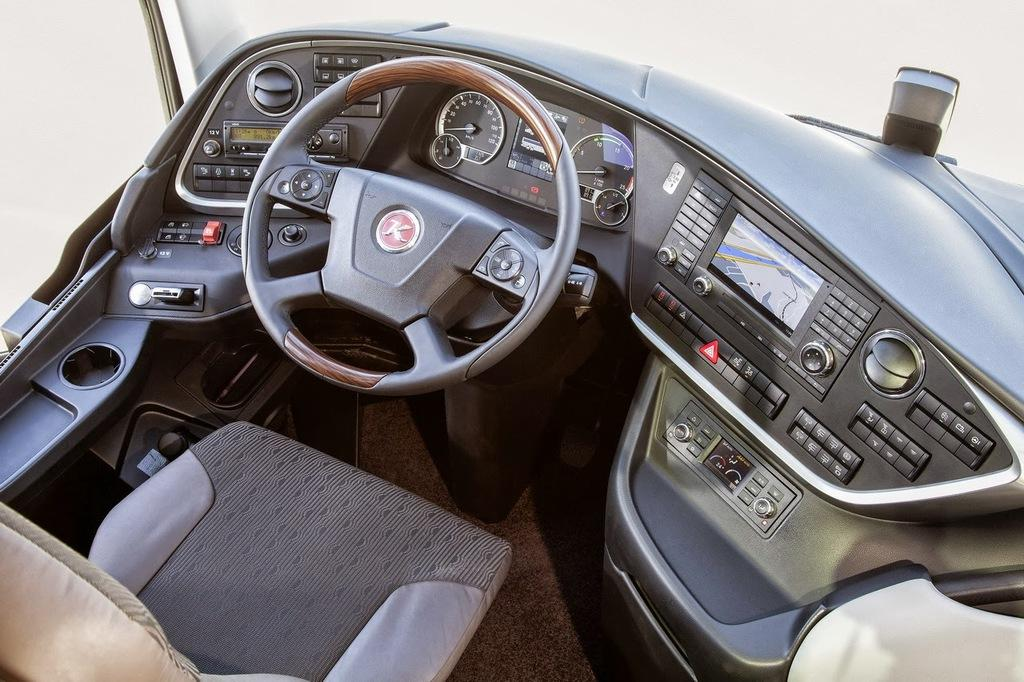What type of location is depicted in the image? The image is an inside view of a vehicle. What is the primary control mechanism in the vehicle? There is a steering wheel in the image. What type of controls are present in the vehicle? There are buttons in the image. What type of seating is available in the vehicle? There is a seat in the image. What type of information can be monitored in the vehicle? There are gauges in the image. What type of display is present in the vehicle? There is a screen in the image. What other unspecified objects can be seen in the image? There are some unspecified objects in the image. What type of drum can be seen in the image? There is no drum present in the image; it is an inside view of a vehicle with various controls and components. What type of minister is depicted in the image? There is no minister present in the image; it is an inside view of a vehicle with various controls and components. 